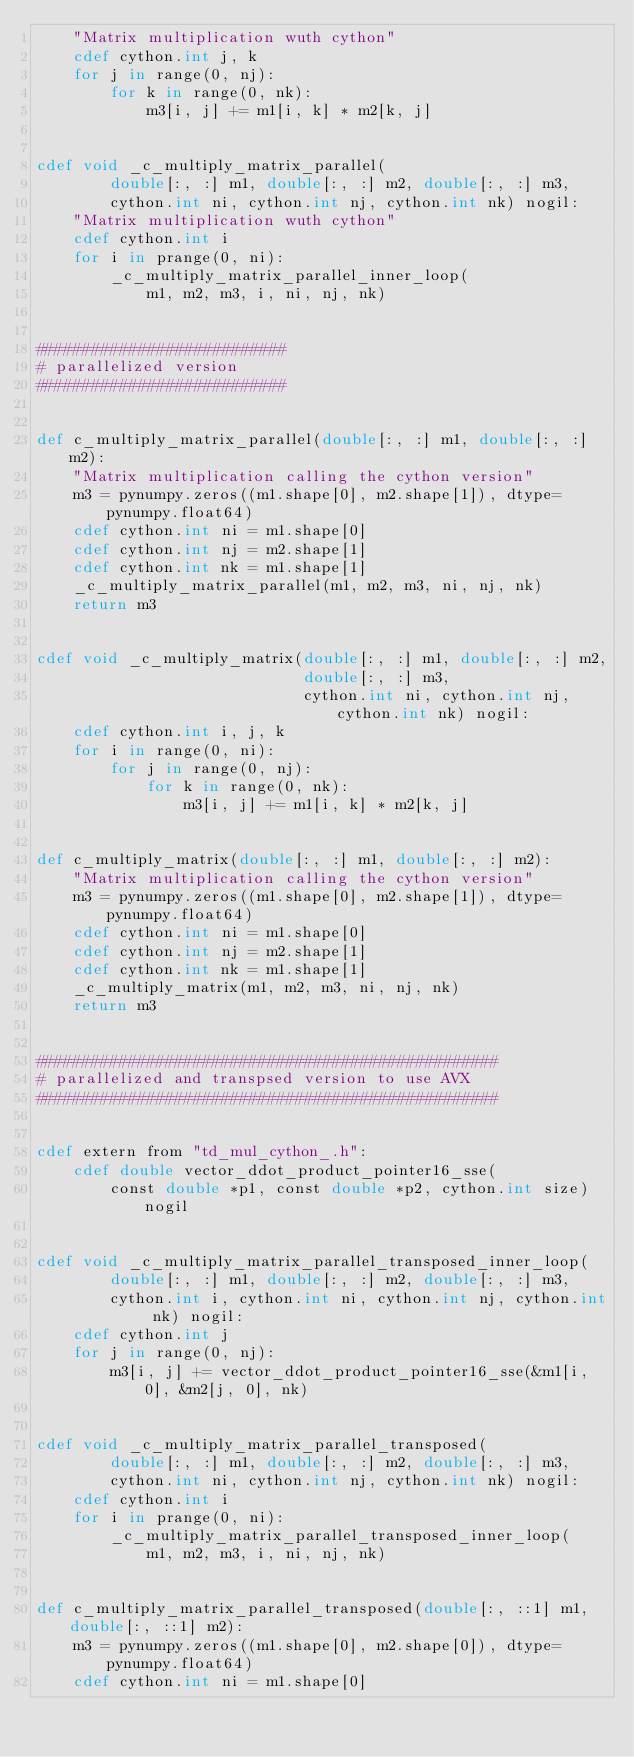Convert code to text. <code><loc_0><loc_0><loc_500><loc_500><_Cython_>    "Matrix multiplication wuth cython"
    cdef cython.int j, k 
    for j in range(0, nj):
        for k in range(0, nk):
            m3[i, j] += m1[i, k] * m2[k, j]


cdef void _c_multiply_matrix_parallel(
        double[:, :] m1, double[:, :] m2, double[:, :] m3,
        cython.int ni, cython.int nj, cython.int nk) nogil:
    "Matrix multiplication wuth cython"
    cdef cython.int i
    for i in prange(0, ni):
        _c_multiply_matrix_parallel_inner_loop(
            m1, m2, m3, i, ni, nj, nk)


###########################
# parallelized version
###########################


def c_multiply_matrix_parallel(double[:, :] m1, double[:, :] m2):
    "Matrix multiplication calling the cython version"
    m3 = pynumpy.zeros((m1.shape[0], m2.shape[1]), dtype=pynumpy.float64)
    cdef cython.int ni = m1.shape[0]
    cdef cython.int nj = m2.shape[1]
    cdef cython.int nk = m1.shape[1]
    _c_multiply_matrix_parallel(m1, m2, m3, ni, nj, nk)
    return m3


cdef void _c_multiply_matrix(double[:, :] m1, double[:, :] m2,
                             double[:, :] m3,
                             cython.int ni, cython.int nj, cython.int nk) nogil:
    cdef cython.int i, j, k    
    for i in range(0, ni):
        for j in range(0, nj):
            for k in range(0, nk):
                m3[i, j] += m1[i, k] * m2[k, j]


def c_multiply_matrix(double[:, :] m1, double[:, :] m2):
    "Matrix multiplication calling the cython version"
    m3 = pynumpy.zeros((m1.shape[0], m2.shape[1]), dtype=pynumpy.float64)
    cdef cython.int ni = m1.shape[0]
    cdef cython.int nj = m2.shape[1]
    cdef cython.int nk = m1.shape[1]
    _c_multiply_matrix(m1, m2, m3, ni, nj, nk)
    return m3


##################################################
# parallelized and transpsed version to use AVX
##################################################


cdef extern from "td_mul_cython_.h":
    cdef double vector_ddot_product_pointer16_sse(
        const double *p1, const double *p2, cython.int size) nogil


cdef void _c_multiply_matrix_parallel_transposed_inner_loop(
        double[:, :] m1, double[:, :] m2, double[:, :] m3,
        cython.int i, cython.int ni, cython.int nj, cython.int nk) nogil:
    cdef cython.int j
    for j in range(0, nj):
        m3[i, j] += vector_ddot_product_pointer16_sse(&m1[i, 0], &m2[j, 0], nk)


cdef void _c_multiply_matrix_parallel_transposed(
        double[:, :] m1, double[:, :] m2, double[:, :] m3,
        cython.int ni, cython.int nj, cython.int nk) nogil:
    cdef cython.int i
    for i in prange(0, ni):
        _c_multiply_matrix_parallel_transposed_inner_loop(
            m1, m2, m3, i, ni, nj, nk)


def c_multiply_matrix_parallel_transposed(double[:, ::1] m1, double[:, ::1] m2):
    m3 = pynumpy.zeros((m1.shape[0], m2.shape[0]), dtype=pynumpy.float64)
    cdef cython.int ni = m1.shape[0]</code> 